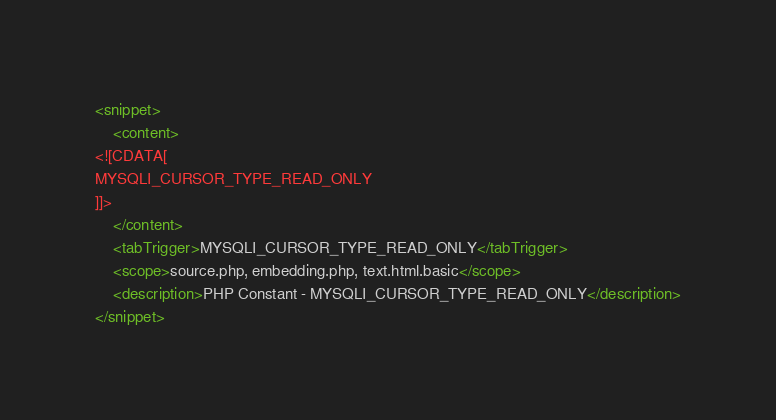<code> <loc_0><loc_0><loc_500><loc_500><_XML_><snippet>
	<content>
<![CDATA[
MYSQLI_CURSOR_TYPE_READ_ONLY
]]>
	</content>
	<tabTrigger>MYSQLI_CURSOR_TYPE_READ_ONLY</tabTrigger>
	<scope>source.php, embedding.php, text.html.basic</scope>
	<description>PHP Constant - MYSQLI_CURSOR_TYPE_READ_ONLY</description>
</snippet></code> 